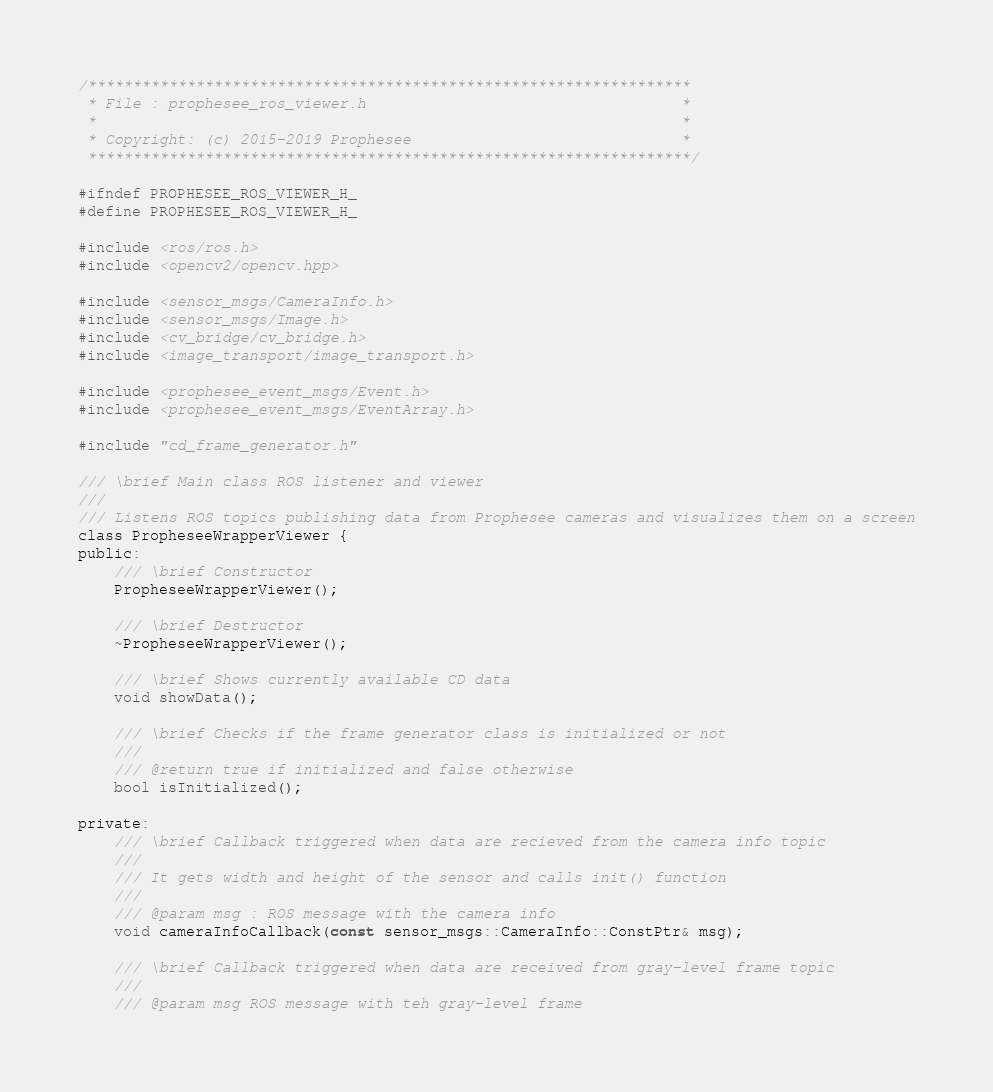<code> <loc_0><loc_0><loc_500><loc_500><_C_>/*******************************************************************
 * File : prophesee_ros_viewer.h                                   *
 *                                                                 *
 * Copyright: (c) 2015-2019 Prophesee                              *
 *******************************************************************/

#ifndef PROPHESEE_ROS_VIEWER_H_
#define PROPHESEE_ROS_VIEWER_H_

#include <ros/ros.h>
#include <opencv2/opencv.hpp>

#include <sensor_msgs/CameraInfo.h>
#include <sensor_msgs/Image.h>
#include <cv_bridge/cv_bridge.h>
#include <image_transport/image_transport.h>

#include <prophesee_event_msgs/Event.h>
#include <prophesee_event_msgs/EventArray.h>

#include "cd_frame_generator.h"

/// \brief Main class ROS listener and viewer
///
/// Listens ROS topics publishing data from Prophesee cameras and visualizes them on a screen
class PropheseeWrapperViewer {
public:
    /// \brief Constructor
    PropheseeWrapperViewer();

    /// \brief Destructor
    ~PropheseeWrapperViewer();

    /// \brief Shows currently available CD data
    void showData();

    /// \brief Checks if the frame generator class is initialized or not
    ///
    /// @return true if initialized and false otherwise
    bool isInitialized();

private:
    /// \brief Callback triggered when data are recieved from the camera info topic
    ///
    /// It gets width and height of the sensor and calls init() function
    ///
    /// @param msg : ROS message with the camera info
    void cameraInfoCallback(const sensor_msgs::CameraInfo::ConstPtr& msg);

    /// \brief Callback triggered when data are received from gray-level frame topic
    ///
    /// @param msg ROS message with teh gray-level frame</code> 